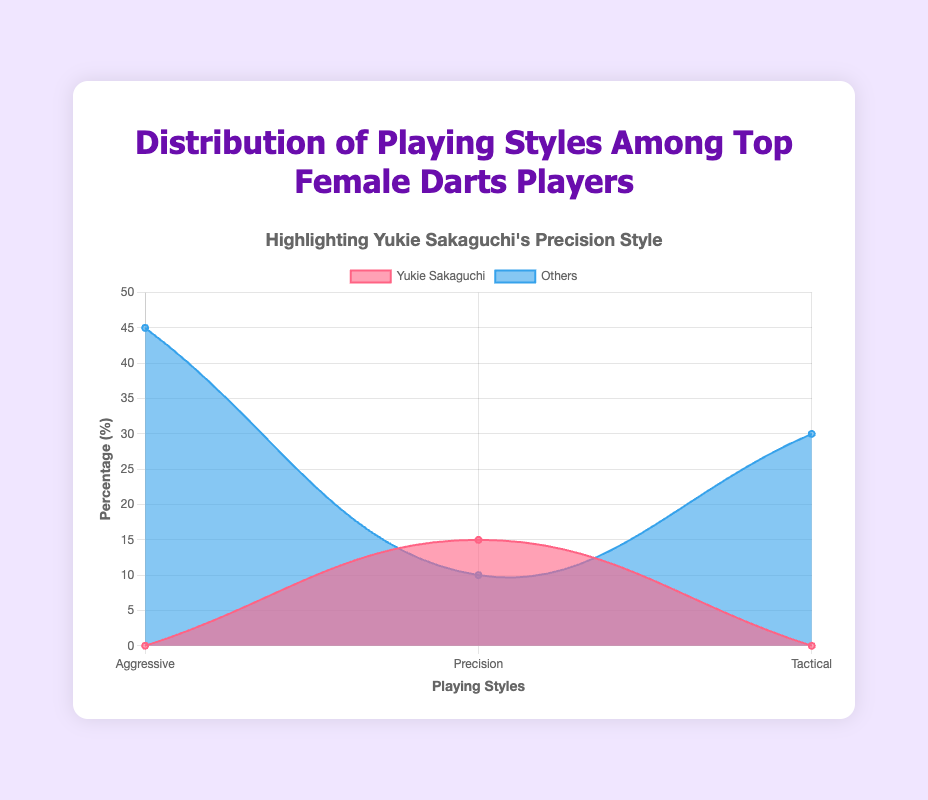What is the title of the chart? The title of the chart is displayed at the top of the figure. It reads "Distribution of Playing Styles Among Top Female Darts Players".
Answer: Distribution of Playing Styles Among Top Female Darts Players Which playing style is Yukie Sakaguchi associated with? Yukie Sakaguchi's playing style is highlighted in the title and in the legend. The style associated with her is "Precision".
Answer: Precision How many playing styles are represented in the chart? The x-axis of the chart shows the different playing styles. There are three labels: "Aggressive," "Precision," and "Tactical".
Answer: 3 What is the highest percentage among the "Aggressive" playing style? By looking at the height of the area for "Aggressive," you can see that it starts at 45%.
Answer: 45% What percentage of players use the "Tactical" style? The "Tactical" style percentage, shown as a data point on the x-axis for "Tactical," reaches 30%.
Answer: 30% Who has a higher percentage in "Precision" style, Yukie Sakaguchi or Lisa Ashton? From the area representing "Precision" style, Yukie Sakaguchi's percentage is 15%, and Lisa Ashton’s is 10%. Comparing these values, Yukie Sakaguchi has the higher percentage.
Answer: Yukie Sakaguchi Among the "Aggressive" and "Tactical" styles, which has the higher total percentage? Adding Aggressive percentages (25+20=45%) and comparing with Tactical (18+12=30%), Aggressive style has a higher total percentage.
Answer: Aggressive Which player's style is highlighted in both the title and the legend? The text of the title specifically mentions focusing on Yukie Sakaguchi's style, and the legend identifies her with a red-colored area.
Answer: Yukie Sakaguchi What is the combined percentage of Mikuru Suzuki and Fallon Sherrock? Mikuru Suzuki has 25% and Fallon Sherrock has 20% in the "Aggressive" style. Adding them together: 25% + 20% = 45%.
Answer: 45% What style has the least representation by percentage? By checking the height of the areas, the smallest value is in "Precision" with others totaling up to 10% and 15%, but other styles (Aggressive, Tactical) have larger combined percentages.
Answer: Precision 